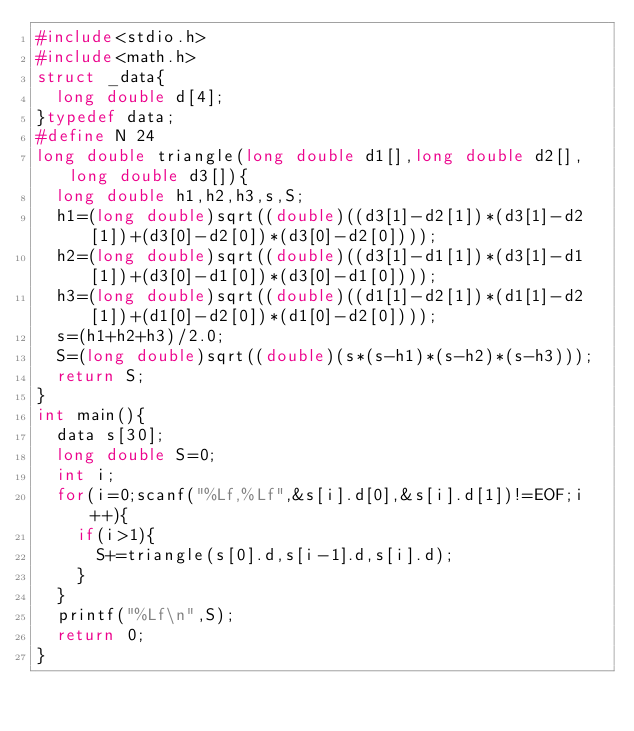<code> <loc_0><loc_0><loc_500><loc_500><_C_>#include<stdio.h>
#include<math.h>
struct _data{
	long double d[4];
}typedef data;
#define N 24
long double triangle(long double d1[],long double d2[], long double d3[]){
	long double h1,h2,h3,s,S;
	h1=(long double)sqrt((double)((d3[1]-d2[1])*(d3[1]-d2[1])+(d3[0]-d2[0])*(d3[0]-d2[0])));
	h2=(long double)sqrt((double)((d3[1]-d1[1])*(d3[1]-d1[1])+(d3[0]-d1[0])*(d3[0]-d1[0])));
	h3=(long double)sqrt((double)((d1[1]-d2[1])*(d1[1]-d2[1])+(d1[0]-d2[0])*(d1[0]-d2[0])));
	s=(h1+h2+h3)/2.0;
	S=(long double)sqrt((double)(s*(s-h1)*(s-h2)*(s-h3)));
	return S;
}
int main(){
	data s[30];
	long double S=0;
	int i;
	for(i=0;scanf("%Lf,%Lf",&s[i].d[0],&s[i].d[1])!=EOF;i++){
		if(i>1){
			S+=triangle(s[0].d,s[i-1].d,s[i].d);
		}
	}
	printf("%Lf\n",S);
	return 0;
}</code> 